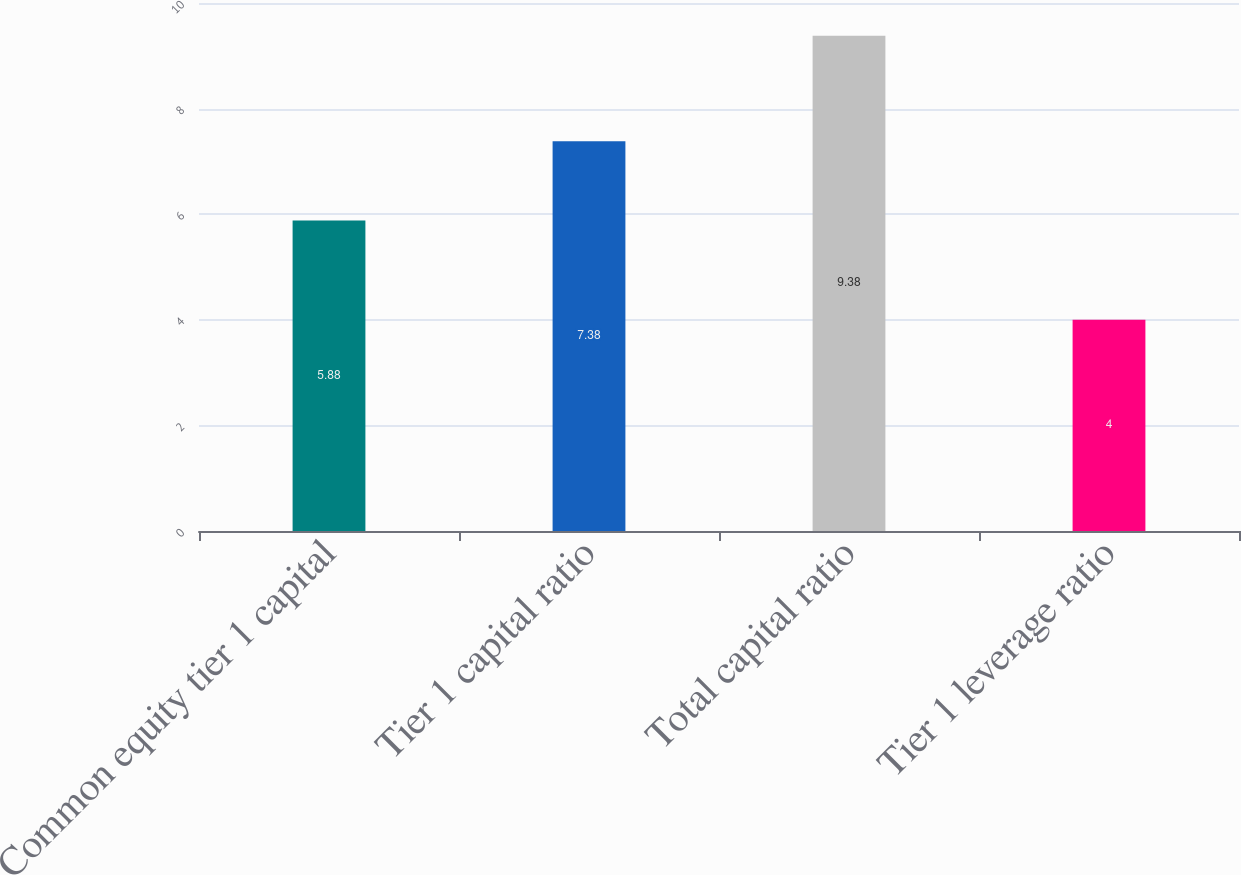<chart> <loc_0><loc_0><loc_500><loc_500><bar_chart><fcel>Common equity tier 1 capital<fcel>Tier 1 capital ratio<fcel>Total capital ratio<fcel>Tier 1 leverage ratio<nl><fcel>5.88<fcel>7.38<fcel>9.38<fcel>4<nl></chart> 